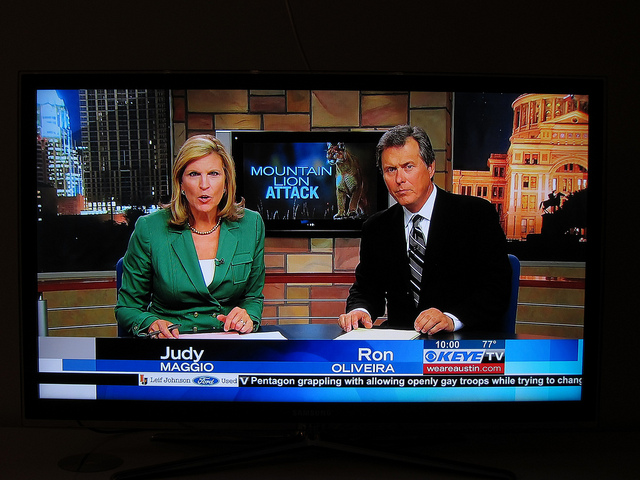Please transcribe the text in this image. MOUNTAIN LION OLIVERIRA MAGGIOP KEYE 10:00 77 weareaustin.com TV chan to Ron trying while troops gay openly allowing with grappling Pentagon V Johnson Judy ATTACK 